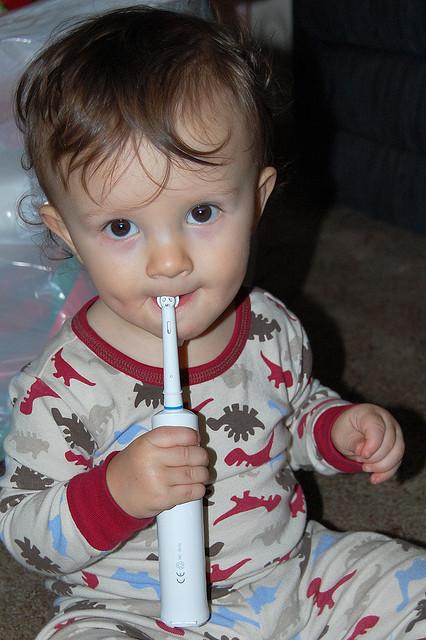Is the child a boy or girl?
Short answer required. Boy. What is the kid doing?
Answer briefly. Brushing his teeth. Is this an electric or manual toothbrush?
Give a very brief answer. Electric. Is the baby brushing it's teeth?
Answer briefly. Yes. 